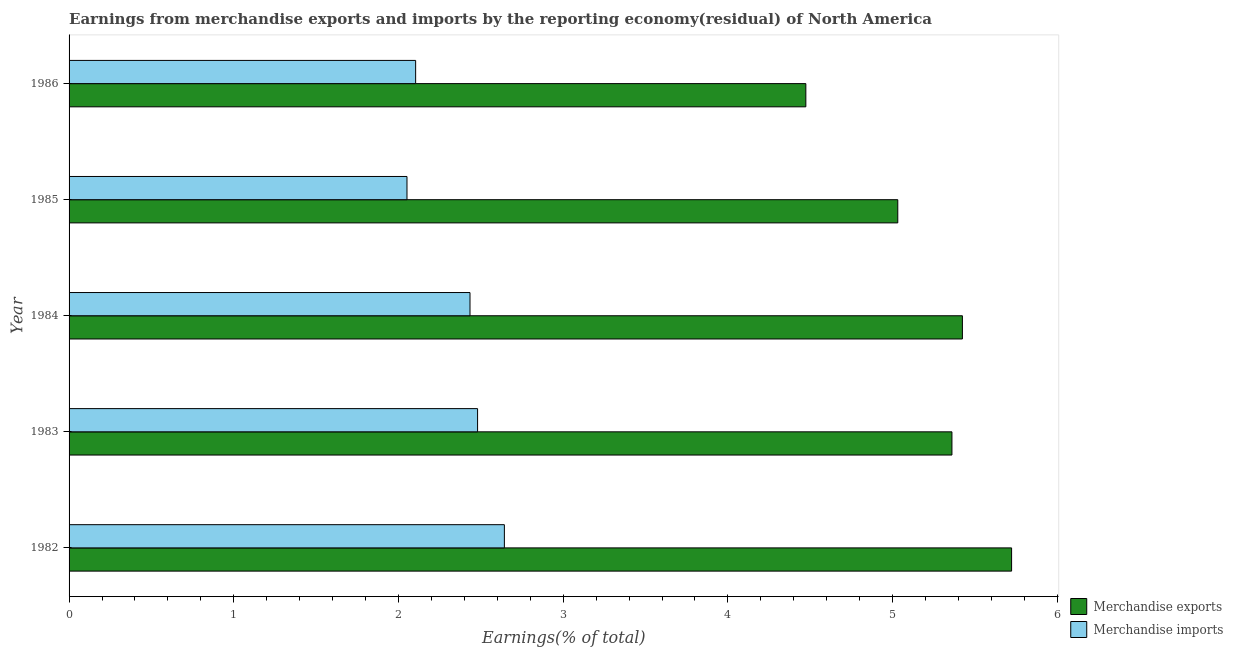How many different coloured bars are there?
Keep it short and to the point. 2. How many groups of bars are there?
Provide a short and direct response. 5. Are the number of bars per tick equal to the number of legend labels?
Offer a very short reply. Yes. How many bars are there on the 4th tick from the top?
Provide a succinct answer. 2. How many bars are there on the 3rd tick from the bottom?
Make the answer very short. 2. What is the earnings from merchandise imports in 1984?
Your answer should be compact. 2.43. Across all years, what is the maximum earnings from merchandise imports?
Provide a short and direct response. 2.64. Across all years, what is the minimum earnings from merchandise exports?
Give a very brief answer. 4.47. In which year was the earnings from merchandise exports maximum?
Provide a succinct answer. 1982. In which year was the earnings from merchandise imports minimum?
Offer a terse response. 1985. What is the total earnings from merchandise exports in the graph?
Make the answer very short. 26.01. What is the difference between the earnings from merchandise imports in 1984 and that in 1986?
Make the answer very short. 0.33. What is the difference between the earnings from merchandise imports in 1986 and the earnings from merchandise exports in 1982?
Your response must be concise. -3.62. What is the average earnings from merchandise imports per year?
Keep it short and to the point. 2.34. In the year 1983, what is the difference between the earnings from merchandise exports and earnings from merchandise imports?
Give a very brief answer. 2.88. In how many years, is the earnings from merchandise exports greater than 5 %?
Offer a very short reply. 4. What is the ratio of the earnings from merchandise imports in 1983 to that in 1986?
Offer a very short reply. 1.18. What is the difference between the highest and the second highest earnings from merchandise imports?
Provide a succinct answer. 0.16. What is the difference between the highest and the lowest earnings from merchandise exports?
Give a very brief answer. 1.25. In how many years, is the earnings from merchandise imports greater than the average earnings from merchandise imports taken over all years?
Give a very brief answer. 3. Is the sum of the earnings from merchandise imports in 1982 and 1986 greater than the maximum earnings from merchandise exports across all years?
Your response must be concise. No. What does the 2nd bar from the top in 1985 represents?
Ensure brevity in your answer.  Merchandise exports. What does the 1st bar from the bottom in 1985 represents?
Keep it short and to the point. Merchandise exports. How many years are there in the graph?
Give a very brief answer. 5. What is the difference between two consecutive major ticks on the X-axis?
Make the answer very short. 1. Does the graph contain any zero values?
Provide a short and direct response. No. Does the graph contain grids?
Keep it short and to the point. No. How many legend labels are there?
Ensure brevity in your answer.  2. How are the legend labels stacked?
Provide a succinct answer. Vertical. What is the title of the graph?
Your response must be concise. Earnings from merchandise exports and imports by the reporting economy(residual) of North America. Does "Lower secondary rate" appear as one of the legend labels in the graph?
Your response must be concise. No. What is the label or title of the X-axis?
Provide a succinct answer. Earnings(% of total). What is the label or title of the Y-axis?
Provide a succinct answer. Year. What is the Earnings(% of total) of Merchandise exports in 1982?
Keep it short and to the point. 5.72. What is the Earnings(% of total) in Merchandise imports in 1982?
Provide a short and direct response. 2.64. What is the Earnings(% of total) in Merchandise exports in 1983?
Ensure brevity in your answer.  5.36. What is the Earnings(% of total) in Merchandise imports in 1983?
Provide a succinct answer. 2.48. What is the Earnings(% of total) in Merchandise exports in 1984?
Ensure brevity in your answer.  5.42. What is the Earnings(% of total) of Merchandise imports in 1984?
Keep it short and to the point. 2.43. What is the Earnings(% of total) of Merchandise exports in 1985?
Keep it short and to the point. 5.03. What is the Earnings(% of total) in Merchandise imports in 1985?
Keep it short and to the point. 2.05. What is the Earnings(% of total) of Merchandise exports in 1986?
Your response must be concise. 4.47. What is the Earnings(% of total) in Merchandise imports in 1986?
Keep it short and to the point. 2.1. Across all years, what is the maximum Earnings(% of total) of Merchandise exports?
Keep it short and to the point. 5.72. Across all years, what is the maximum Earnings(% of total) in Merchandise imports?
Your answer should be very brief. 2.64. Across all years, what is the minimum Earnings(% of total) in Merchandise exports?
Offer a terse response. 4.47. Across all years, what is the minimum Earnings(% of total) in Merchandise imports?
Your answer should be compact. 2.05. What is the total Earnings(% of total) of Merchandise exports in the graph?
Your answer should be very brief. 26.01. What is the total Earnings(% of total) in Merchandise imports in the graph?
Offer a terse response. 11.71. What is the difference between the Earnings(% of total) in Merchandise exports in 1982 and that in 1983?
Provide a short and direct response. 0.36. What is the difference between the Earnings(% of total) in Merchandise imports in 1982 and that in 1983?
Make the answer very short. 0.16. What is the difference between the Earnings(% of total) of Merchandise exports in 1982 and that in 1984?
Give a very brief answer. 0.3. What is the difference between the Earnings(% of total) of Merchandise imports in 1982 and that in 1984?
Give a very brief answer. 0.21. What is the difference between the Earnings(% of total) of Merchandise exports in 1982 and that in 1985?
Ensure brevity in your answer.  0.69. What is the difference between the Earnings(% of total) in Merchandise imports in 1982 and that in 1985?
Your response must be concise. 0.59. What is the difference between the Earnings(% of total) of Merchandise exports in 1982 and that in 1986?
Offer a very short reply. 1.25. What is the difference between the Earnings(% of total) of Merchandise imports in 1982 and that in 1986?
Offer a terse response. 0.54. What is the difference between the Earnings(% of total) in Merchandise exports in 1983 and that in 1984?
Provide a succinct answer. -0.06. What is the difference between the Earnings(% of total) in Merchandise imports in 1983 and that in 1984?
Your answer should be compact. 0.05. What is the difference between the Earnings(% of total) in Merchandise exports in 1983 and that in 1985?
Your answer should be very brief. 0.33. What is the difference between the Earnings(% of total) in Merchandise imports in 1983 and that in 1985?
Make the answer very short. 0.43. What is the difference between the Earnings(% of total) of Merchandise exports in 1983 and that in 1986?
Offer a terse response. 0.89. What is the difference between the Earnings(% of total) of Merchandise imports in 1983 and that in 1986?
Make the answer very short. 0.38. What is the difference between the Earnings(% of total) in Merchandise exports in 1984 and that in 1985?
Provide a short and direct response. 0.39. What is the difference between the Earnings(% of total) in Merchandise imports in 1984 and that in 1985?
Ensure brevity in your answer.  0.38. What is the difference between the Earnings(% of total) in Merchandise exports in 1984 and that in 1986?
Ensure brevity in your answer.  0.95. What is the difference between the Earnings(% of total) in Merchandise imports in 1984 and that in 1986?
Give a very brief answer. 0.33. What is the difference between the Earnings(% of total) in Merchandise exports in 1985 and that in 1986?
Keep it short and to the point. 0.56. What is the difference between the Earnings(% of total) of Merchandise imports in 1985 and that in 1986?
Your response must be concise. -0.05. What is the difference between the Earnings(% of total) of Merchandise exports in 1982 and the Earnings(% of total) of Merchandise imports in 1983?
Offer a terse response. 3.24. What is the difference between the Earnings(% of total) in Merchandise exports in 1982 and the Earnings(% of total) in Merchandise imports in 1984?
Provide a short and direct response. 3.29. What is the difference between the Earnings(% of total) in Merchandise exports in 1982 and the Earnings(% of total) in Merchandise imports in 1985?
Your answer should be very brief. 3.67. What is the difference between the Earnings(% of total) of Merchandise exports in 1982 and the Earnings(% of total) of Merchandise imports in 1986?
Provide a short and direct response. 3.62. What is the difference between the Earnings(% of total) of Merchandise exports in 1983 and the Earnings(% of total) of Merchandise imports in 1984?
Provide a short and direct response. 2.93. What is the difference between the Earnings(% of total) of Merchandise exports in 1983 and the Earnings(% of total) of Merchandise imports in 1985?
Make the answer very short. 3.31. What is the difference between the Earnings(% of total) in Merchandise exports in 1983 and the Earnings(% of total) in Merchandise imports in 1986?
Make the answer very short. 3.26. What is the difference between the Earnings(% of total) of Merchandise exports in 1984 and the Earnings(% of total) of Merchandise imports in 1985?
Your answer should be very brief. 3.37. What is the difference between the Earnings(% of total) in Merchandise exports in 1984 and the Earnings(% of total) in Merchandise imports in 1986?
Provide a short and direct response. 3.32. What is the difference between the Earnings(% of total) of Merchandise exports in 1985 and the Earnings(% of total) of Merchandise imports in 1986?
Your response must be concise. 2.93. What is the average Earnings(% of total) in Merchandise exports per year?
Give a very brief answer. 5.2. What is the average Earnings(% of total) of Merchandise imports per year?
Provide a short and direct response. 2.34. In the year 1982, what is the difference between the Earnings(% of total) in Merchandise exports and Earnings(% of total) in Merchandise imports?
Provide a short and direct response. 3.08. In the year 1983, what is the difference between the Earnings(% of total) of Merchandise exports and Earnings(% of total) of Merchandise imports?
Your answer should be compact. 2.88. In the year 1984, what is the difference between the Earnings(% of total) of Merchandise exports and Earnings(% of total) of Merchandise imports?
Offer a very short reply. 2.99. In the year 1985, what is the difference between the Earnings(% of total) of Merchandise exports and Earnings(% of total) of Merchandise imports?
Your answer should be very brief. 2.98. In the year 1986, what is the difference between the Earnings(% of total) of Merchandise exports and Earnings(% of total) of Merchandise imports?
Offer a terse response. 2.37. What is the ratio of the Earnings(% of total) in Merchandise exports in 1982 to that in 1983?
Offer a terse response. 1.07. What is the ratio of the Earnings(% of total) of Merchandise imports in 1982 to that in 1983?
Provide a succinct answer. 1.07. What is the ratio of the Earnings(% of total) of Merchandise exports in 1982 to that in 1984?
Provide a succinct answer. 1.06. What is the ratio of the Earnings(% of total) of Merchandise imports in 1982 to that in 1984?
Provide a short and direct response. 1.09. What is the ratio of the Earnings(% of total) in Merchandise exports in 1982 to that in 1985?
Offer a terse response. 1.14. What is the ratio of the Earnings(% of total) in Merchandise imports in 1982 to that in 1985?
Offer a terse response. 1.29. What is the ratio of the Earnings(% of total) in Merchandise exports in 1982 to that in 1986?
Make the answer very short. 1.28. What is the ratio of the Earnings(% of total) in Merchandise imports in 1982 to that in 1986?
Your response must be concise. 1.26. What is the ratio of the Earnings(% of total) in Merchandise exports in 1983 to that in 1984?
Your answer should be very brief. 0.99. What is the ratio of the Earnings(% of total) in Merchandise imports in 1983 to that in 1984?
Give a very brief answer. 1.02. What is the ratio of the Earnings(% of total) of Merchandise exports in 1983 to that in 1985?
Offer a very short reply. 1.07. What is the ratio of the Earnings(% of total) in Merchandise imports in 1983 to that in 1985?
Give a very brief answer. 1.21. What is the ratio of the Earnings(% of total) in Merchandise exports in 1983 to that in 1986?
Give a very brief answer. 1.2. What is the ratio of the Earnings(% of total) of Merchandise imports in 1983 to that in 1986?
Your answer should be very brief. 1.18. What is the ratio of the Earnings(% of total) in Merchandise exports in 1984 to that in 1985?
Offer a very short reply. 1.08. What is the ratio of the Earnings(% of total) in Merchandise imports in 1984 to that in 1985?
Offer a very short reply. 1.19. What is the ratio of the Earnings(% of total) of Merchandise exports in 1984 to that in 1986?
Keep it short and to the point. 1.21. What is the ratio of the Earnings(% of total) of Merchandise imports in 1984 to that in 1986?
Give a very brief answer. 1.16. What is the ratio of the Earnings(% of total) of Merchandise exports in 1985 to that in 1986?
Your answer should be compact. 1.12. What is the ratio of the Earnings(% of total) of Merchandise imports in 1985 to that in 1986?
Make the answer very short. 0.97. What is the difference between the highest and the second highest Earnings(% of total) in Merchandise exports?
Keep it short and to the point. 0.3. What is the difference between the highest and the second highest Earnings(% of total) of Merchandise imports?
Keep it short and to the point. 0.16. What is the difference between the highest and the lowest Earnings(% of total) in Merchandise exports?
Your response must be concise. 1.25. What is the difference between the highest and the lowest Earnings(% of total) of Merchandise imports?
Make the answer very short. 0.59. 